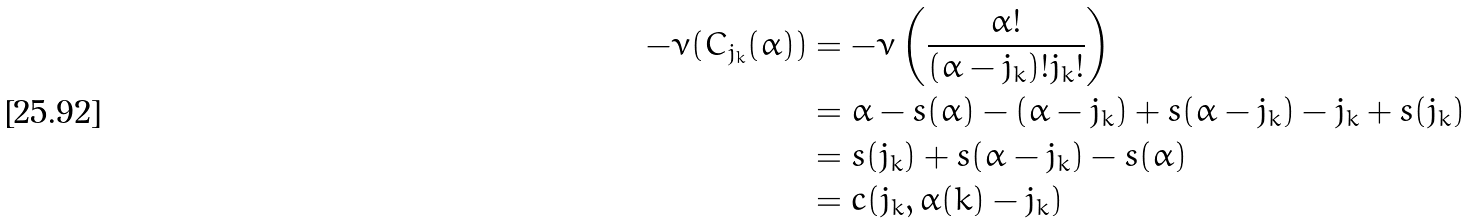Convert formula to latex. <formula><loc_0><loc_0><loc_500><loc_500>- \nu ( C _ { j _ { k } } ( \alpha ) ) & = - \nu \left ( \frac { \alpha ! } { ( \alpha - j _ { k } ) ! j _ { k } ! } \right ) \\ & = \alpha - s ( \alpha ) - ( \alpha - j _ { k } ) + s ( \alpha - j _ { k } ) - j _ { k } + s ( j _ { k } ) \\ & = s ( j _ { k } ) + s ( \alpha - j _ { k } ) - s ( \alpha ) \\ & = c ( j _ { k } , \alpha ( k ) - j _ { k } )</formula> 